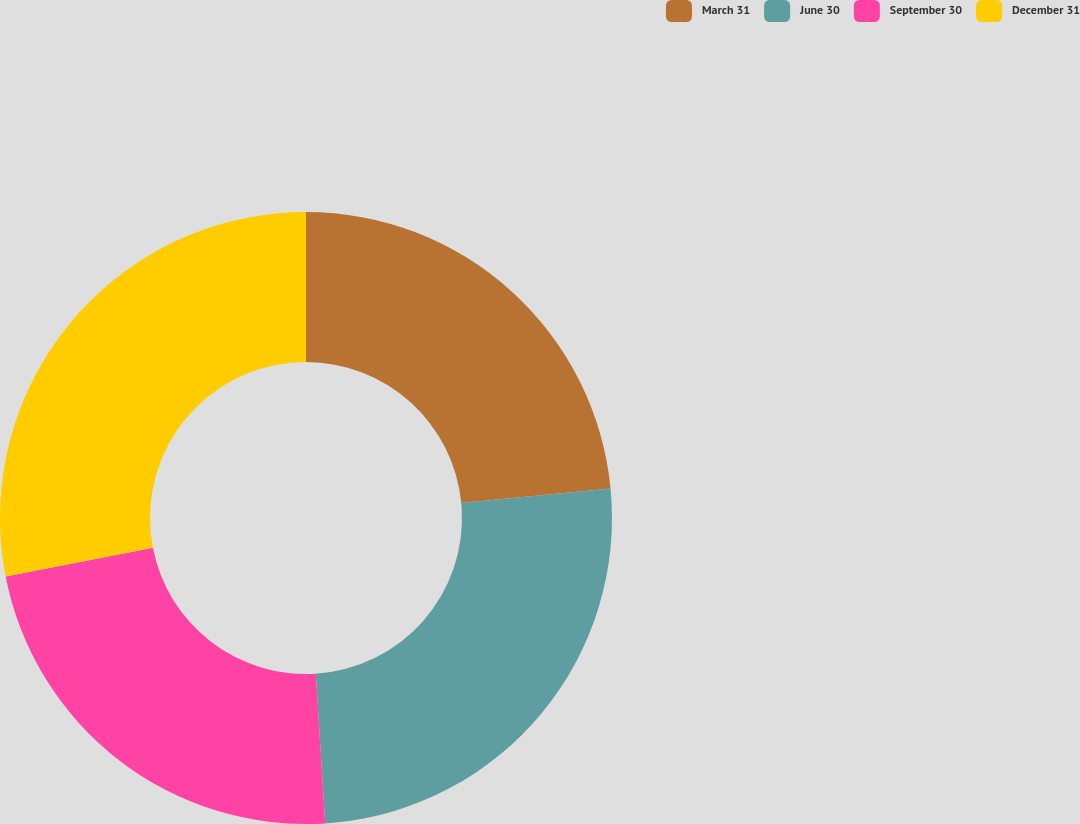<chart> <loc_0><loc_0><loc_500><loc_500><pie_chart><fcel>March 31<fcel>June 30<fcel>September 30<fcel>December 31<nl><fcel>23.46%<fcel>25.54%<fcel>22.94%<fcel>28.06%<nl></chart> 